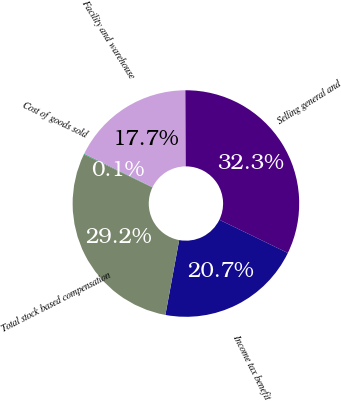Convert chart. <chart><loc_0><loc_0><loc_500><loc_500><pie_chart><fcel>Cost of goods sold<fcel>Facility and warehouse<fcel>Selling general and<fcel>Income tax benefit<fcel>Total stock based compensation<nl><fcel>0.11%<fcel>17.68%<fcel>32.27%<fcel>20.71%<fcel>29.23%<nl></chart> 